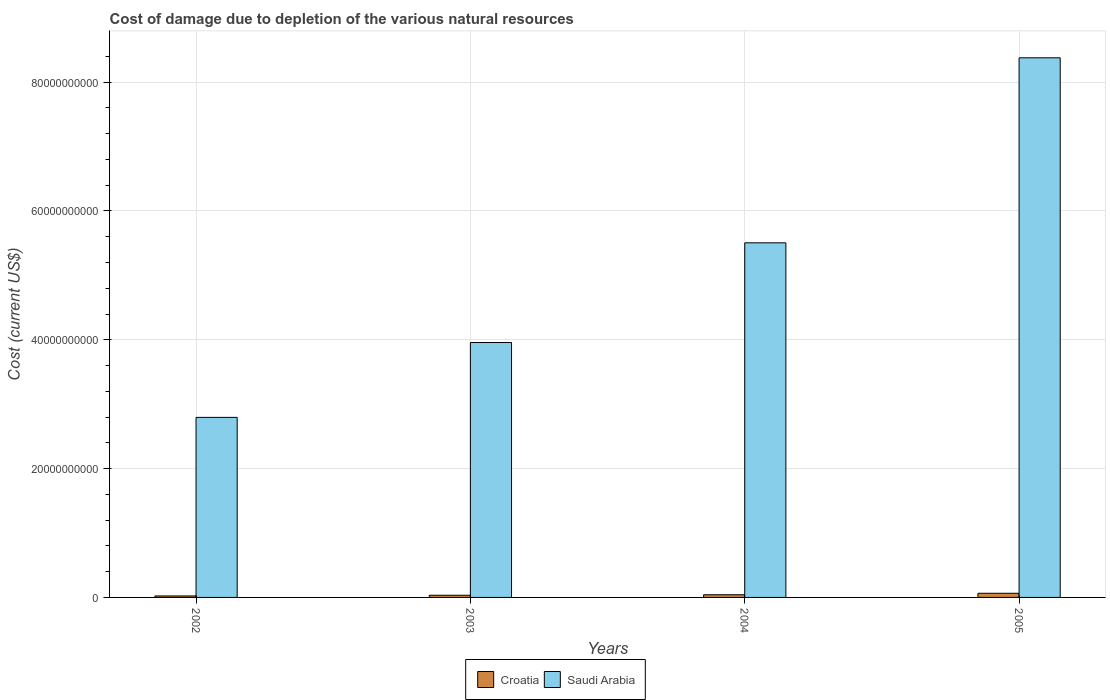How many different coloured bars are there?
Your response must be concise. 2. Are the number of bars per tick equal to the number of legend labels?
Give a very brief answer. Yes. How many bars are there on the 2nd tick from the left?
Provide a short and direct response. 2. What is the label of the 2nd group of bars from the left?
Your answer should be compact. 2003. In how many cases, is the number of bars for a given year not equal to the number of legend labels?
Offer a terse response. 0. What is the cost of damage caused due to the depletion of various natural resources in Croatia in 2005?
Your response must be concise. 6.46e+08. Across all years, what is the maximum cost of damage caused due to the depletion of various natural resources in Saudi Arabia?
Make the answer very short. 8.38e+1. Across all years, what is the minimum cost of damage caused due to the depletion of various natural resources in Saudi Arabia?
Offer a terse response. 2.80e+1. In which year was the cost of damage caused due to the depletion of various natural resources in Croatia maximum?
Your response must be concise. 2005. What is the total cost of damage caused due to the depletion of various natural resources in Croatia in the graph?
Keep it short and to the point. 1.63e+09. What is the difference between the cost of damage caused due to the depletion of various natural resources in Saudi Arabia in 2003 and that in 2004?
Provide a succinct answer. -1.55e+1. What is the difference between the cost of damage caused due to the depletion of various natural resources in Croatia in 2003 and the cost of damage caused due to the depletion of various natural resources in Saudi Arabia in 2004?
Ensure brevity in your answer.  -5.47e+1. What is the average cost of damage caused due to the depletion of various natural resources in Saudi Arabia per year?
Offer a very short reply. 5.16e+1. In the year 2004, what is the difference between the cost of damage caused due to the depletion of various natural resources in Croatia and cost of damage caused due to the depletion of various natural resources in Saudi Arabia?
Provide a succinct answer. -5.46e+1. What is the ratio of the cost of damage caused due to the depletion of various natural resources in Croatia in 2003 to that in 2004?
Ensure brevity in your answer.  0.82. Is the cost of damage caused due to the depletion of various natural resources in Croatia in 2002 less than that in 2004?
Offer a terse response. Yes. What is the difference between the highest and the second highest cost of damage caused due to the depletion of various natural resources in Saudi Arabia?
Provide a short and direct response. 2.87e+1. What is the difference between the highest and the lowest cost of damage caused due to the depletion of various natural resources in Croatia?
Provide a short and direct response. 4.14e+08. What does the 2nd bar from the left in 2003 represents?
Give a very brief answer. Saudi Arabia. What does the 1st bar from the right in 2005 represents?
Your response must be concise. Saudi Arabia. How many bars are there?
Offer a terse response. 8. How many years are there in the graph?
Make the answer very short. 4. Does the graph contain any zero values?
Offer a very short reply. No. Does the graph contain grids?
Your response must be concise. Yes. Where does the legend appear in the graph?
Offer a terse response. Bottom center. How are the legend labels stacked?
Give a very brief answer. Horizontal. What is the title of the graph?
Offer a terse response. Cost of damage due to depletion of the various natural resources. What is the label or title of the X-axis?
Ensure brevity in your answer.  Years. What is the label or title of the Y-axis?
Offer a very short reply. Cost (current US$). What is the Cost (current US$) of Croatia in 2002?
Keep it short and to the point. 2.31e+08. What is the Cost (current US$) in Saudi Arabia in 2002?
Offer a very short reply. 2.80e+1. What is the Cost (current US$) of Croatia in 2003?
Make the answer very short. 3.40e+08. What is the Cost (current US$) in Saudi Arabia in 2003?
Keep it short and to the point. 3.96e+1. What is the Cost (current US$) of Croatia in 2004?
Your answer should be compact. 4.14e+08. What is the Cost (current US$) of Saudi Arabia in 2004?
Your answer should be very brief. 5.51e+1. What is the Cost (current US$) in Croatia in 2005?
Your answer should be very brief. 6.46e+08. What is the Cost (current US$) of Saudi Arabia in 2005?
Your answer should be compact. 8.38e+1. Across all years, what is the maximum Cost (current US$) in Croatia?
Keep it short and to the point. 6.46e+08. Across all years, what is the maximum Cost (current US$) of Saudi Arabia?
Ensure brevity in your answer.  8.38e+1. Across all years, what is the minimum Cost (current US$) of Croatia?
Ensure brevity in your answer.  2.31e+08. Across all years, what is the minimum Cost (current US$) of Saudi Arabia?
Offer a terse response. 2.80e+1. What is the total Cost (current US$) of Croatia in the graph?
Offer a very short reply. 1.63e+09. What is the total Cost (current US$) of Saudi Arabia in the graph?
Give a very brief answer. 2.06e+11. What is the difference between the Cost (current US$) of Croatia in 2002 and that in 2003?
Make the answer very short. -1.08e+08. What is the difference between the Cost (current US$) of Saudi Arabia in 2002 and that in 2003?
Give a very brief answer. -1.16e+1. What is the difference between the Cost (current US$) of Croatia in 2002 and that in 2004?
Your answer should be very brief. -1.83e+08. What is the difference between the Cost (current US$) of Saudi Arabia in 2002 and that in 2004?
Offer a very short reply. -2.71e+1. What is the difference between the Cost (current US$) in Croatia in 2002 and that in 2005?
Your answer should be very brief. -4.14e+08. What is the difference between the Cost (current US$) in Saudi Arabia in 2002 and that in 2005?
Offer a very short reply. -5.58e+1. What is the difference between the Cost (current US$) in Croatia in 2003 and that in 2004?
Offer a terse response. -7.47e+07. What is the difference between the Cost (current US$) in Saudi Arabia in 2003 and that in 2004?
Offer a terse response. -1.55e+1. What is the difference between the Cost (current US$) in Croatia in 2003 and that in 2005?
Make the answer very short. -3.06e+08. What is the difference between the Cost (current US$) in Saudi Arabia in 2003 and that in 2005?
Make the answer very short. -4.42e+1. What is the difference between the Cost (current US$) in Croatia in 2004 and that in 2005?
Keep it short and to the point. -2.31e+08. What is the difference between the Cost (current US$) in Saudi Arabia in 2004 and that in 2005?
Offer a terse response. -2.87e+1. What is the difference between the Cost (current US$) of Croatia in 2002 and the Cost (current US$) of Saudi Arabia in 2003?
Your answer should be compact. -3.93e+1. What is the difference between the Cost (current US$) of Croatia in 2002 and the Cost (current US$) of Saudi Arabia in 2004?
Provide a short and direct response. -5.48e+1. What is the difference between the Cost (current US$) in Croatia in 2002 and the Cost (current US$) in Saudi Arabia in 2005?
Keep it short and to the point. -8.35e+1. What is the difference between the Cost (current US$) in Croatia in 2003 and the Cost (current US$) in Saudi Arabia in 2004?
Make the answer very short. -5.47e+1. What is the difference between the Cost (current US$) in Croatia in 2003 and the Cost (current US$) in Saudi Arabia in 2005?
Give a very brief answer. -8.34e+1. What is the difference between the Cost (current US$) in Croatia in 2004 and the Cost (current US$) in Saudi Arabia in 2005?
Your answer should be very brief. -8.34e+1. What is the average Cost (current US$) of Croatia per year?
Ensure brevity in your answer.  4.08e+08. What is the average Cost (current US$) in Saudi Arabia per year?
Keep it short and to the point. 5.16e+1. In the year 2002, what is the difference between the Cost (current US$) in Croatia and Cost (current US$) in Saudi Arabia?
Provide a short and direct response. -2.77e+1. In the year 2003, what is the difference between the Cost (current US$) in Croatia and Cost (current US$) in Saudi Arabia?
Make the answer very short. -3.92e+1. In the year 2004, what is the difference between the Cost (current US$) in Croatia and Cost (current US$) in Saudi Arabia?
Offer a terse response. -5.46e+1. In the year 2005, what is the difference between the Cost (current US$) of Croatia and Cost (current US$) of Saudi Arabia?
Offer a very short reply. -8.31e+1. What is the ratio of the Cost (current US$) of Croatia in 2002 to that in 2003?
Offer a terse response. 0.68. What is the ratio of the Cost (current US$) in Saudi Arabia in 2002 to that in 2003?
Make the answer very short. 0.71. What is the ratio of the Cost (current US$) in Croatia in 2002 to that in 2004?
Offer a terse response. 0.56. What is the ratio of the Cost (current US$) in Saudi Arabia in 2002 to that in 2004?
Make the answer very short. 0.51. What is the ratio of the Cost (current US$) in Croatia in 2002 to that in 2005?
Your answer should be compact. 0.36. What is the ratio of the Cost (current US$) in Saudi Arabia in 2002 to that in 2005?
Your answer should be compact. 0.33. What is the ratio of the Cost (current US$) of Croatia in 2003 to that in 2004?
Your answer should be very brief. 0.82. What is the ratio of the Cost (current US$) of Saudi Arabia in 2003 to that in 2004?
Offer a very short reply. 0.72. What is the ratio of the Cost (current US$) in Croatia in 2003 to that in 2005?
Your answer should be compact. 0.53. What is the ratio of the Cost (current US$) in Saudi Arabia in 2003 to that in 2005?
Provide a short and direct response. 0.47. What is the ratio of the Cost (current US$) of Croatia in 2004 to that in 2005?
Offer a very short reply. 0.64. What is the ratio of the Cost (current US$) of Saudi Arabia in 2004 to that in 2005?
Offer a terse response. 0.66. What is the difference between the highest and the second highest Cost (current US$) in Croatia?
Make the answer very short. 2.31e+08. What is the difference between the highest and the second highest Cost (current US$) of Saudi Arabia?
Make the answer very short. 2.87e+1. What is the difference between the highest and the lowest Cost (current US$) of Croatia?
Your response must be concise. 4.14e+08. What is the difference between the highest and the lowest Cost (current US$) in Saudi Arabia?
Your response must be concise. 5.58e+1. 